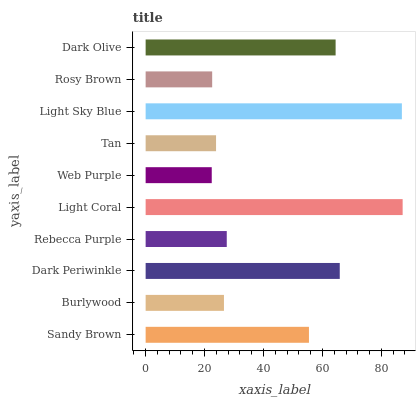Is Web Purple the minimum?
Answer yes or no. Yes. Is Light Coral the maximum?
Answer yes or no. Yes. Is Burlywood the minimum?
Answer yes or no. No. Is Burlywood the maximum?
Answer yes or no. No. Is Sandy Brown greater than Burlywood?
Answer yes or no. Yes. Is Burlywood less than Sandy Brown?
Answer yes or no. Yes. Is Burlywood greater than Sandy Brown?
Answer yes or no. No. Is Sandy Brown less than Burlywood?
Answer yes or no. No. Is Sandy Brown the high median?
Answer yes or no. Yes. Is Rebecca Purple the low median?
Answer yes or no. Yes. Is Dark Periwinkle the high median?
Answer yes or no. No. Is Burlywood the low median?
Answer yes or no. No. 